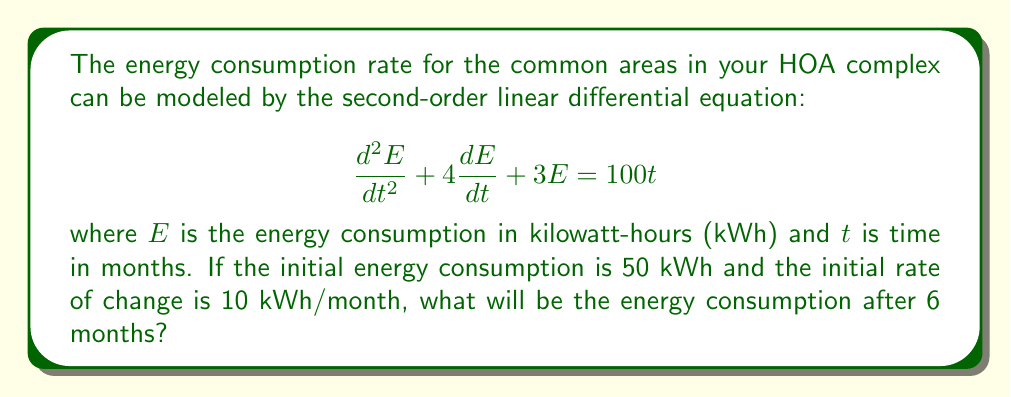Can you solve this math problem? To solve this problem, we need to follow these steps:

1) First, we need to find the general solution to the homogeneous equation:
   $$\frac{d^2E}{dt^2} + 4\frac{dE}{dt} + 3E = 0$$

   The characteristic equation is $r^2 + 4r + 3 = 0$
   Solving this, we get $r = -1$ or $r = -3$
   So, the homogeneous solution is $E_h = c_1e^{-t} + c_2e^{-3t}$

2) Next, we need to find a particular solution. Given the right side is $100t$, we can assume a particular solution of the form $E_p = At + B$

   Substituting this into the original equation:
   $$0 + 4A + 3(At + B) = 100t$$
   
   Equating coefficients:
   $3A = 100$, so $A = \frac{100}{3}$
   $4A + 3B = 0$, so $B = -\frac{400}{9}$

   Thus, $E_p = \frac{100}{3}t - \frac{400}{9}$

3) The general solution is $E = E_h + E_p = c_1e^{-t} + c_2e^{-3t} + \frac{100}{3}t - \frac{400}{9}$

4) Now we use the initial conditions to find $c_1$ and $c_2$:
   At $t = 0$, $E = 50$ and $\frac{dE}{dt} = 10$

   $50 = c_1 + c_2 - \frac{400}{9}$
   $10 = -c_1 - 3c_2 + \frac{100}{3}$

   Solving these simultaneously:
   $c_1 = \frac{1250}{9}$ and $c_2 = -\frac{400}{9}$

5) Therefore, the particular solution is:
   $$E = \frac{1250}{9}e^{-t} - \frac{400}{9}e^{-3t} + \frac{100}{3}t - \frac{400}{9}$$

6) To find the energy consumption after 6 months, we substitute $t = 6$:
   $$E(6) = \frac{1250}{9}e^{-6} - \frac{400}{9}e^{-18} + \frac{100}{3}(6) - \frac{400}{9}$$

7) Calculating this gives us approximately 189.33 kWh.
Answer: The energy consumption after 6 months will be approximately 189.33 kWh. 